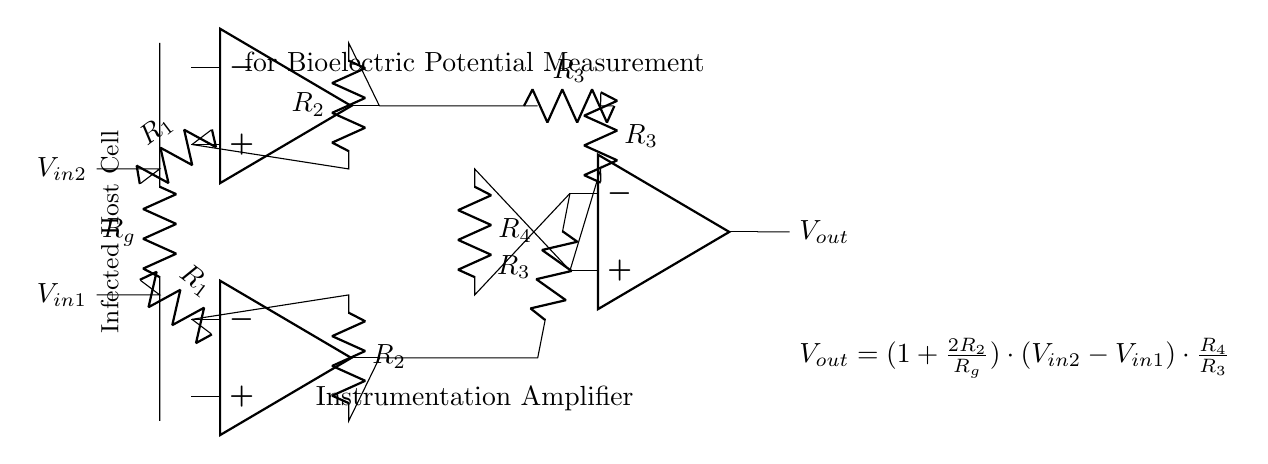What type of amplifier is shown in the diagram? The diagram depicts an instrumentation amplifier, which is specifically designed for precise measurements of small differential signals. The presence of multiple operational amplifiers and feedback resistors indicates a configuration suitable for measuring bioelectric potentials.
Answer: instrumentation amplifier What are the input voltages named in the circuit? The input voltages are labeled as V in1 and V in2, indicating the differential inputs to the instrumentation amplifier. These voltages come from the infected host cells being measured.
Answer: V in1, V in2 What is the purpose of the resistor R g in this amplifier? The resistor R g is the gain setting resistor that influences the overall gain of the instrumentation amplifier by affecting the voltage difference amplified by the circuit. The feedback arrangement indicates its critical role in establishing the gain along with R2.
Answer: gain setting Which component helps to amplify the difference between the two input signals? The differential amplifier stage, specifically the operational amplifier labeled opa3 in the circuit, is responsible for amplifying the difference between the two input voltages, V in2 and V in1.
Answer: opa3 What is the output voltage equation provided in the circuit? The output voltage equation is V out = (1 + (2R2/R g)) * (V in2 - V in1) * (R 4/R 3). This equation shows how the output voltage is calculated based on the input signals and the resistances involved in the circuit.
Answer: V out = (1 + (2R2/R g)) * (V in2 - V in1) * (R 4/R 3) What is the role of the resistors R2 in this circuit? The resistors R2 serve as feedback resistors in the circuit, helping to control the gain of the amplifier's output. Their value in conjunction with Rg adjusts the sensitivity of the instrumentation amplifier to the input signals from the infected host cells.
Answer: feedback resistors How many operational amplifiers are used in this instrumentation amplifier configuration? There are three operational amplifiers as indicated in the circuit diagram. They work together to create the desired amplification and differential measurement capabilities needed for bioelectric potential analysis.
Answer: 3 